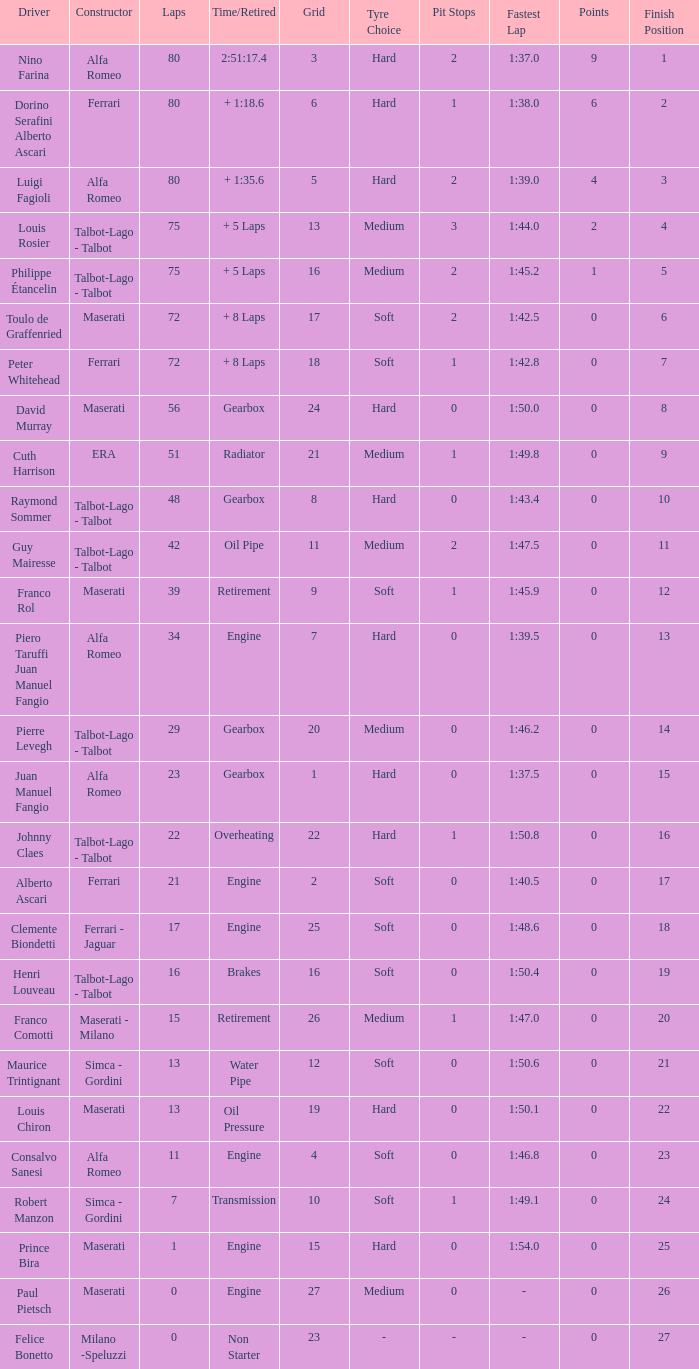What was the smallest grid for Prince bira? 15.0. 